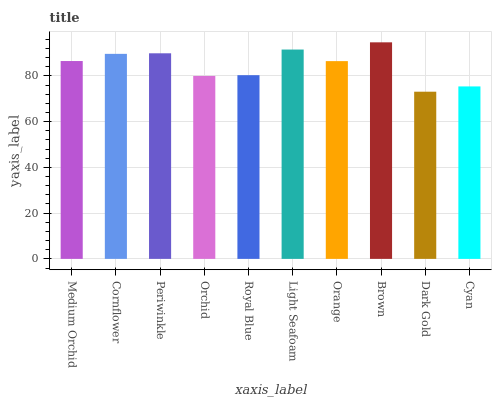Is Dark Gold the minimum?
Answer yes or no. Yes. Is Brown the maximum?
Answer yes or no. Yes. Is Cornflower the minimum?
Answer yes or no. No. Is Cornflower the maximum?
Answer yes or no. No. Is Cornflower greater than Medium Orchid?
Answer yes or no. Yes. Is Medium Orchid less than Cornflower?
Answer yes or no. Yes. Is Medium Orchid greater than Cornflower?
Answer yes or no. No. Is Cornflower less than Medium Orchid?
Answer yes or no. No. Is Medium Orchid the high median?
Answer yes or no. Yes. Is Orange the low median?
Answer yes or no. Yes. Is Cornflower the high median?
Answer yes or no. No. Is Medium Orchid the low median?
Answer yes or no. No. 